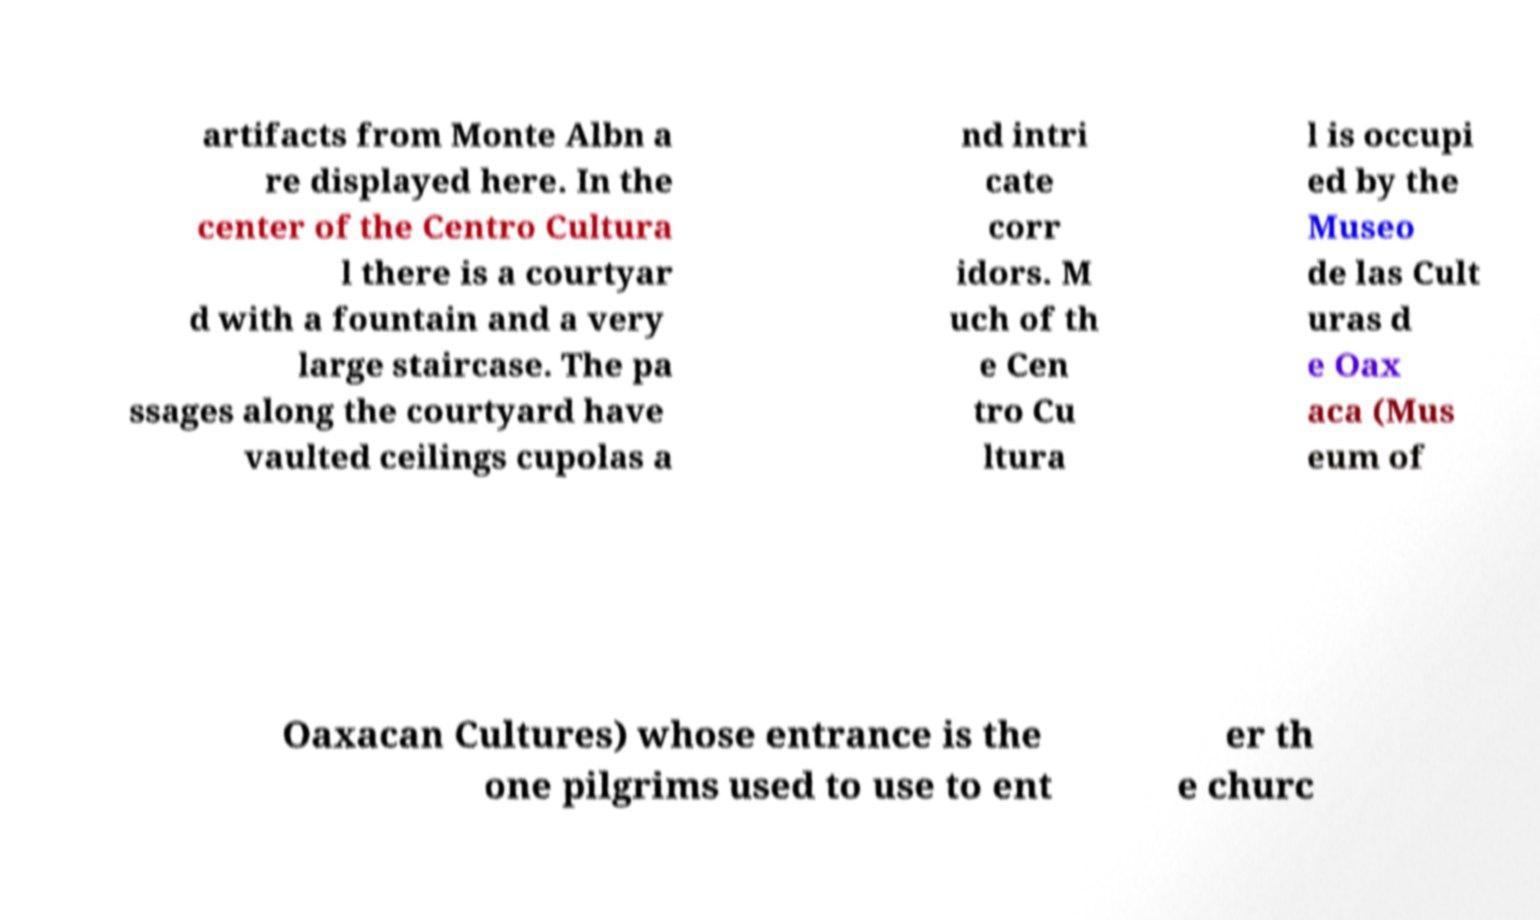Can you read and provide the text displayed in the image?This photo seems to have some interesting text. Can you extract and type it out for me? artifacts from Monte Albn a re displayed here. In the center of the Centro Cultura l there is a courtyar d with a fountain and a very large staircase. The pa ssages along the courtyard have vaulted ceilings cupolas a nd intri cate corr idors. M uch of th e Cen tro Cu ltura l is occupi ed by the Museo de las Cult uras d e Oax aca (Mus eum of Oaxacan Cultures) whose entrance is the one pilgrims used to use to ent er th e churc 